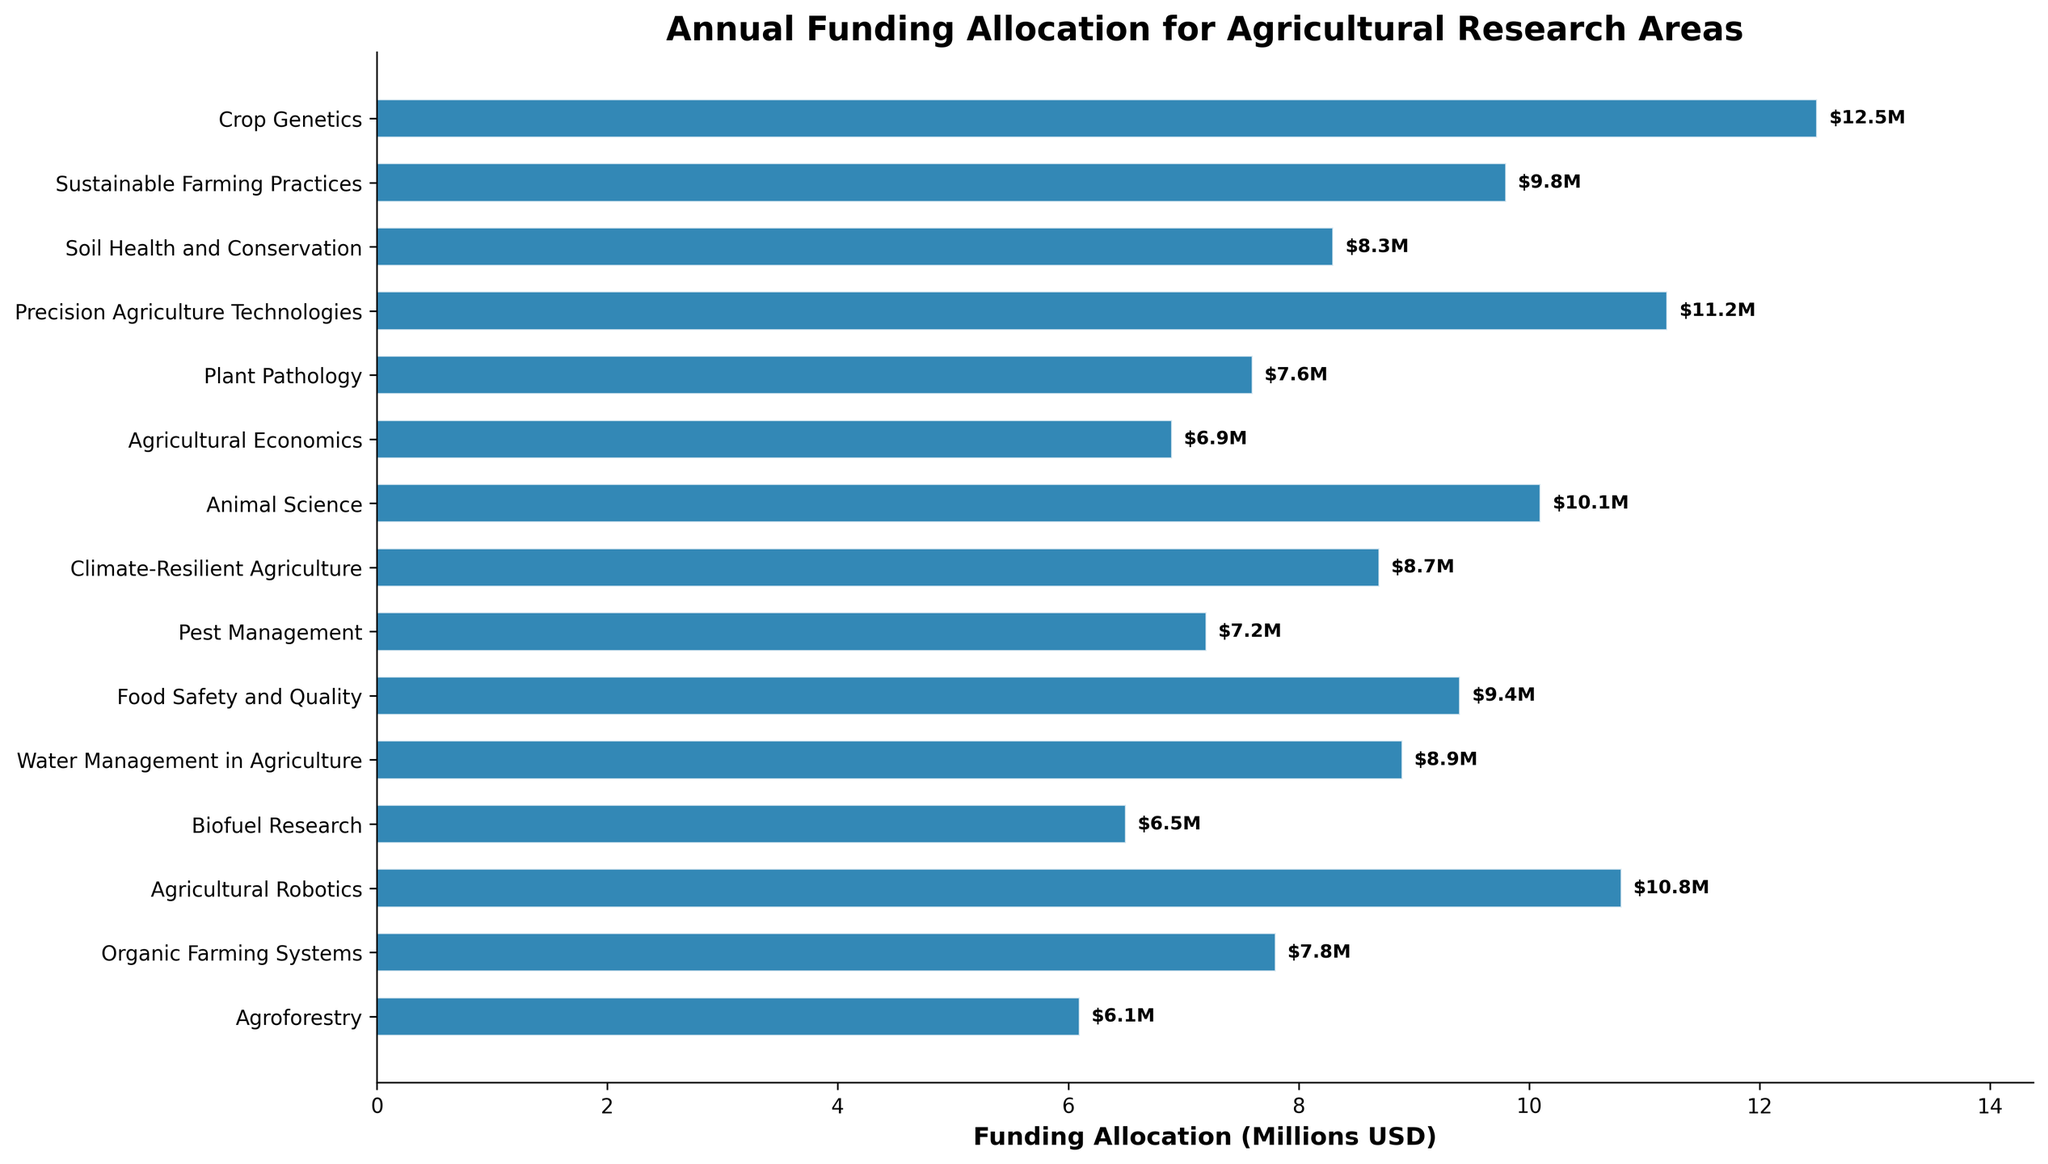What is the highest funding allocation for a research area? To find the highest funding allocation, look at the lengths of the bars and determine which one is the longest. It indicates the highest funding.
Answer: Crop Genetics Which research area received the least funding? Identify the shortest bar on the chart, which represents the lowest funding allocation among the research areas.
Answer: Agroforestry How much more funding does Precision Agriculture Technologies receive compared to Agricultural Economics? First, find the funding allocations for both Precision Agriculture Technologies and Agricultural Economics. Subtract the funding of Agricultural Economics from Precision Agriculture Technologies. Calculation: 11.2 - 6.9
Answer: 4.3 million USD What is the combined funding allocation for Crop Genetics and Animal Science? Add the funding allocations for Crop Genetics and Animal Science. Calculation: 12.5 + 10.1
Answer: 22.6 million USD Which two research areas have the most similar funding allocations? Compare the lengths of the bars visually to find the pairs that are closest in length.
Answer: Soil Health and Conservation (8.3) and Water Management in Agriculture (8.9) How does the funding for Climate-Resilient Agriculture compare to that of Food Safety and Quality? Look at the bars for Climate-Resilient Agriculture and Food Safety and Quality. Determine which bar is longer and by how much.
Answer: Food Safety and Quality received 0.7 million USD more than Climate-Resilient Agriculture What is the average funding allocation for all research areas? Sum the funding allocations for all the research areas and divide by the number of areas. Calculation: (12.5 + 9.8 + 8.3 + 11.2 + 7.6 + 6.9 + 10.1 + 8.7 + 7.2 + 9.4 + 8.9 + 6.5 + 10.8 + 7.8 + 6.1) / 15
Answer: 8.71 million USD Which three research areas receive funding between 7 and 8 million USD? Identify the bars with lengths that correspond to funding allocations between 7 and 8 million USD.
Answer: Plant Pathology, Pest Management, Organic Farming Systems 